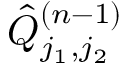Convert formula to latex. <formula><loc_0><loc_0><loc_500><loc_500>\hat { Q } _ { j _ { 1 } , j _ { 2 } } ^ { ( n - 1 ) }</formula> 